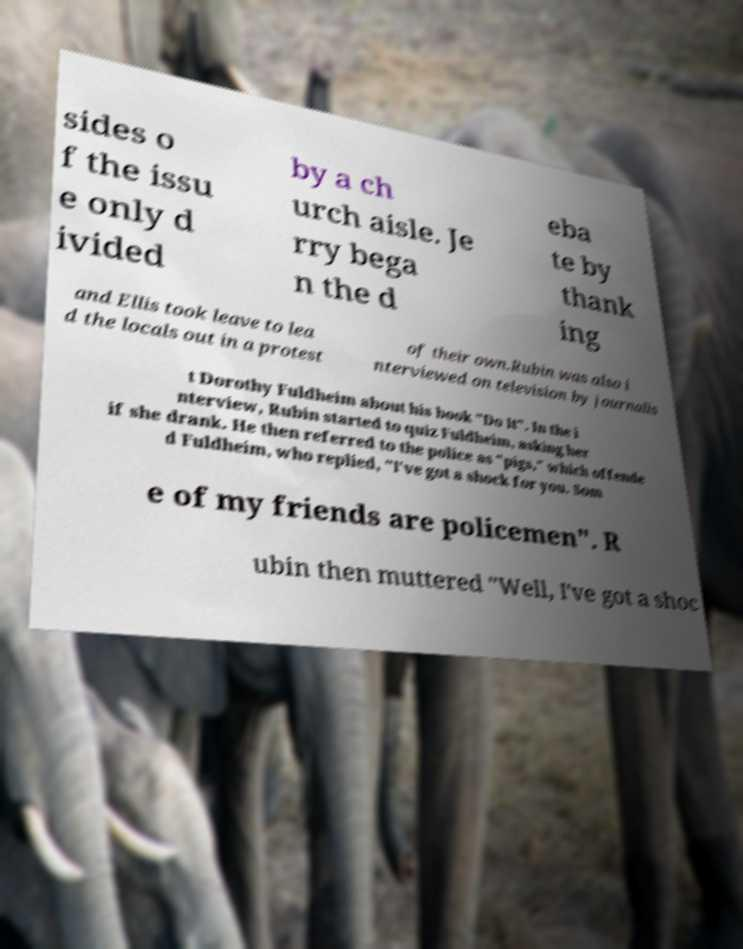Please identify and transcribe the text found in this image. sides o f the issu e only d ivided by a ch urch aisle. Je rry bega n the d eba te by thank ing and Ellis took leave to lea d the locals out in a protest of their own.Rubin was also i nterviewed on television by journalis t Dorothy Fuldheim about his book "Do It". In the i nterview, Rubin started to quiz Fuldheim, asking her if she drank. He then referred to the police as "pigs," which offende d Fuldheim, who replied, "I've got a shock for you. Som e of my friends are policemen". R ubin then muttered "Well, I've got a shoc 